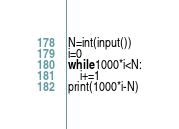Convert code to text. <code><loc_0><loc_0><loc_500><loc_500><_Python_>N=int(input())
i=0
while 1000*i<N:
    i+=1
print(1000*i-N)</code> 